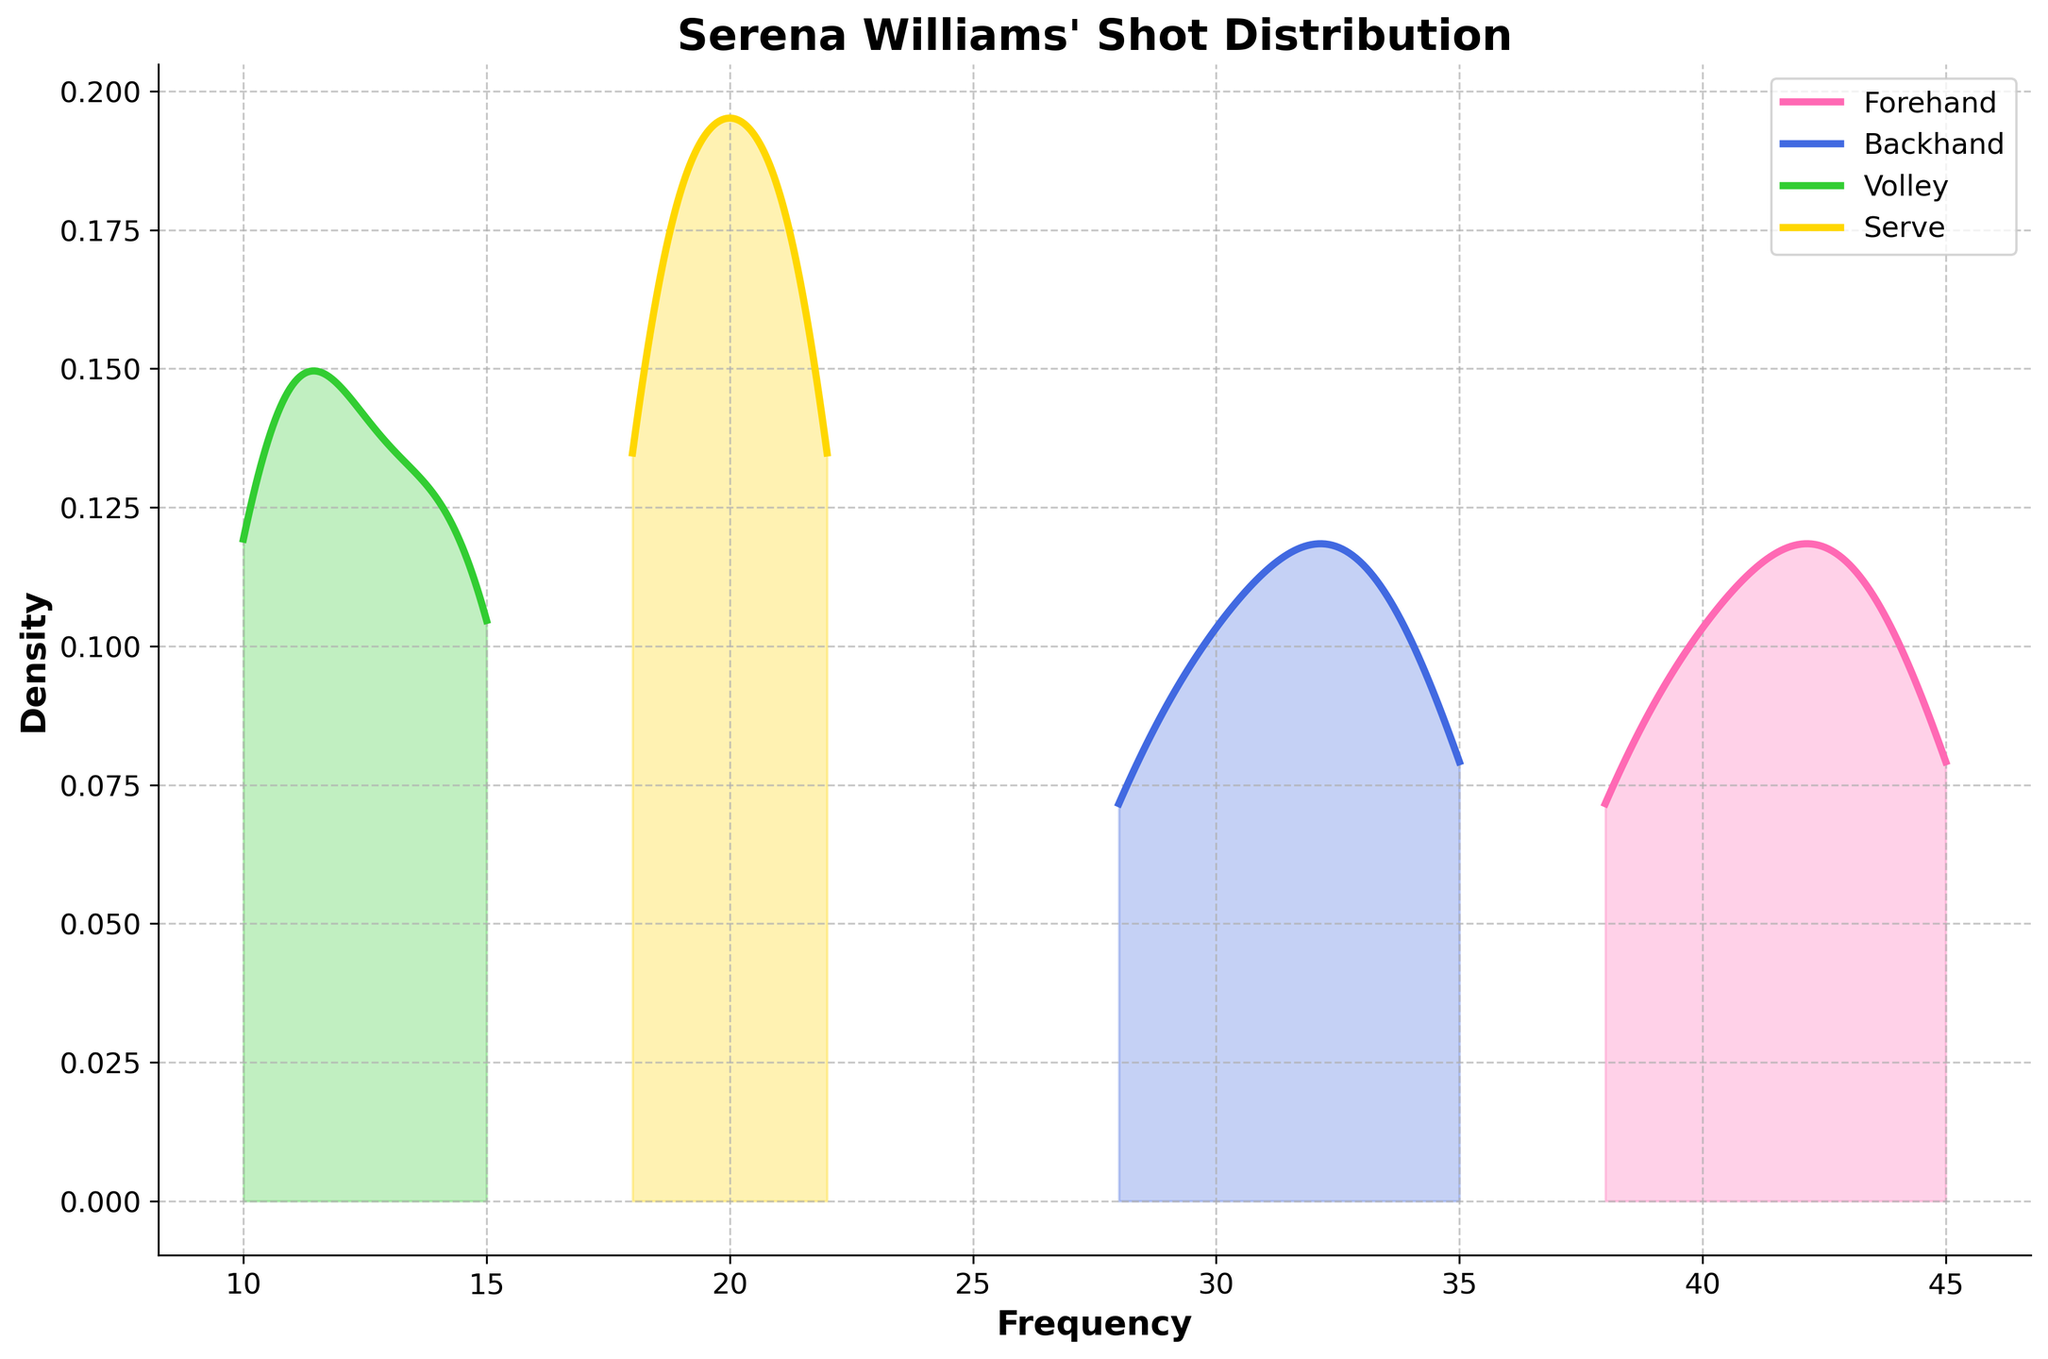What's the title of the figure? The title of the figure is written at the top of the plot, which is "Serena Williams' Shot Distribution".
Answer: Serena Williams' Shot Distribution What are the different shot types displayed in the figure? The legend at the top-right corner of the plot shows the different shot types, which are Forehand, Backhand, Volley, and Serve.
Answer: Forehand, Backhand, Volley, Serve Which shot type has the highest frequency density? By examining the height of the peaks in the density plots, the Forehand type has the highest peak, indicating it has the highest frequency density compared to other shot types.
Answer: Forehand What's the range of frequency values for the Volley shot type? By looking at the x-axis values for the region where the Volley density plot is present, the range of the frequency values is from 10 to 15.
Answer: 10 to 15 How does the distribution of Serve shots compare to Backhand shots? The density plot shows that Serve shots have a tighter distribution centered around the 20-22 frequency range, whereas Backhand shots are more spread out, ranging from about 28 to 35.
Answer: Serve is tighter, Backhand is more spread out Which shot type has the most spread-out distribution? By observing the width of the density plots, the Backhand shot type, ranging from 28 to 35, has the widest spread-out distribution.
Answer: Backhand What is the maximum frequency value for the forehand shot type in the plot? The plot shows the forehand distribution range on the x-axis to max out at approximately 45.
Answer: 45 What's the color representing the Serve shot type? The legend indicates that Serve shots are represented by a golden-yellow color in the plot.
Answer: Golden-yellow How does the density of forehand shots at frequency 42 compare to that of backhand shots at the same frequency? By looking at the vertical heights of the density plots at frequency 42, the forehand density is higher compared to backhand, which has no observations at 42.
Answer: Higher for forehand 